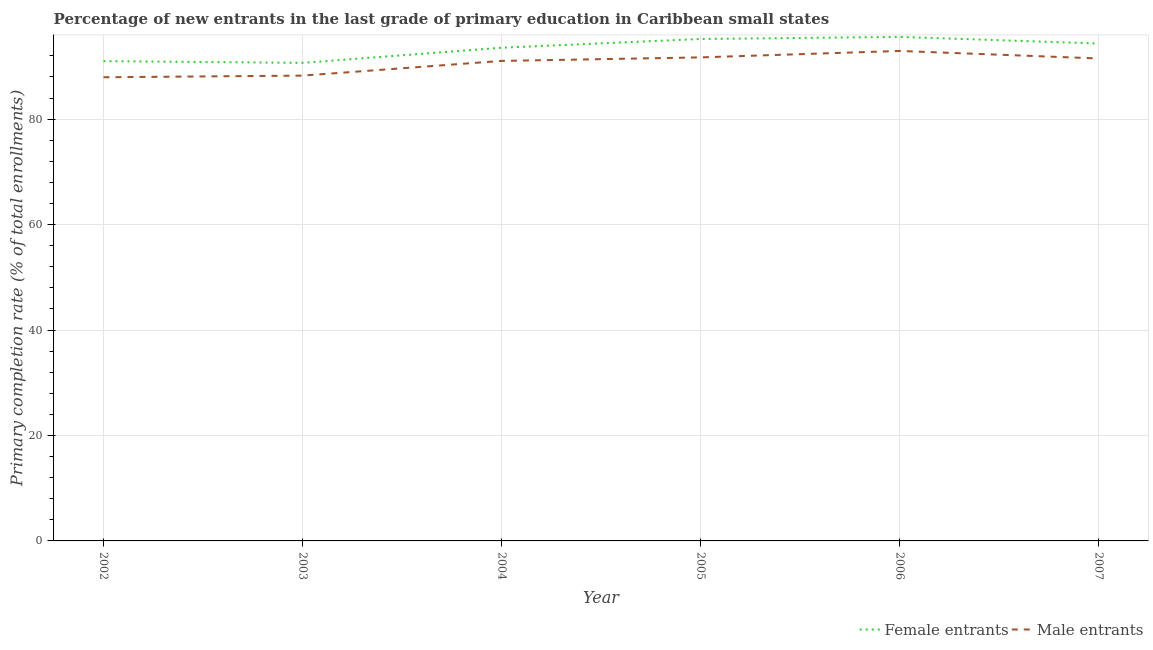How many different coloured lines are there?
Ensure brevity in your answer.  2. Does the line corresponding to primary completion rate of female entrants intersect with the line corresponding to primary completion rate of male entrants?
Keep it short and to the point. No. What is the primary completion rate of female entrants in 2006?
Make the answer very short. 95.59. Across all years, what is the maximum primary completion rate of female entrants?
Provide a succinct answer. 95.59. Across all years, what is the minimum primary completion rate of female entrants?
Give a very brief answer. 90.66. In which year was the primary completion rate of male entrants minimum?
Ensure brevity in your answer.  2002. What is the total primary completion rate of female entrants in the graph?
Your answer should be compact. 560.32. What is the difference between the primary completion rate of male entrants in 2002 and that in 2005?
Provide a short and direct response. -3.77. What is the difference between the primary completion rate of female entrants in 2007 and the primary completion rate of male entrants in 2002?
Your response must be concise. 6.4. What is the average primary completion rate of male entrants per year?
Your response must be concise. 90.56. In the year 2006, what is the difference between the primary completion rate of male entrants and primary completion rate of female entrants?
Provide a short and direct response. -2.66. In how many years, is the primary completion rate of female entrants greater than 76 %?
Make the answer very short. 6. What is the ratio of the primary completion rate of male entrants in 2002 to that in 2004?
Provide a succinct answer. 0.97. What is the difference between the highest and the second highest primary completion rate of male entrants?
Provide a short and direct response. 1.22. What is the difference between the highest and the lowest primary completion rate of male entrants?
Ensure brevity in your answer.  4.99. In how many years, is the primary completion rate of female entrants greater than the average primary completion rate of female entrants taken over all years?
Your answer should be compact. 4. Is the sum of the primary completion rate of male entrants in 2003 and 2004 greater than the maximum primary completion rate of female entrants across all years?
Provide a short and direct response. Yes. Does the primary completion rate of male entrants monotonically increase over the years?
Your response must be concise. No. How many years are there in the graph?
Ensure brevity in your answer.  6. What is the difference between two consecutive major ticks on the Y-axis?
Your answer should be compact. 20. Does the graph contain grids?
Make the answer very short. Yes. How are the legend labels stacked?
Your answer should be compact. Horizontal. What is the title of the graph?
Provide a succinct answer. Percentage of new entrants in the last grade of primary education in Caribbean small states. Does "International Visitors" appear as one of the legend labels in the graph?
Keep it short and to the point. No. What is the label or title of the Y-axis?
Your answer should be compact. Primary completion rate (% of total enrollments). What is the Primary completion rate (% of total enrollments) in Female entrants in 2002?
Keep it short and to the point. 90.99. What is the Primary completion rate (% of total enrollments) in Male entrants in 2002?
Ensure brevity in your answer.  87.94. What is the Primary completion rate (% of total enrollments) in Female entrants in 2003?
Make the answer very short. 90.66. What is the Primary completion rate (% of total enrollments) of Male entrants in 2003?
Make the answer very short. 88.25. What is the Primary completion rate (% of total enrollments) of Female entrants in 2004?
Make the answer very short. 93.54. What is the Primary completion rate (% of total enrollments) in Male entrants in 2004?
Give a very brief answer. 91.04. What is the Primary completion rate (% of total enrollments) in Female entrants in 2005?
Give a very brief answer. 95.19. What is the Primary completion rate (% of total enrollments) of Male entrants in 2005?
Your response must be concise. 91.71. What is the Primary completion rate (% of total enrollments) in Female entrants in 2006?
Give a very brief answer. 95.59. What is the Primary completion rate (% of total enrollments) of Male entrants in 2006?
Provide a succinct answer. 92.93. What is the Primary completion rate (% of total enrollments) of Female entrants in 2007?
Keep it short and to the point. 94.34. What is the Primary completion rate (% of total enrollments) in Male entrants in 2007?
Your answer should be compact. 91.5. Across all years, what is the maximum Primary completion rate (% of total enrollments) in Female entrants?
Offer a terse response. 95.59. Across all years, what is the maximum Primary completion rate (% of total enrollments) of Male entrants?
Provide a short and direct response. 92.93. Across all years, what is the minimum Primary completion rate (% of total enrollments) in Female entrants?
Offer a terse response. 90.66. Across all years, what is the minimum Primary completion rate (% of total enrollments) of Male entrants?
Ensure brevity in your answer.  87.94. What is the total Primary completion rate (% of total enrollments) in Female entrants in the graph?
Offer a very short reply. 560.32. What is the total Primary completion rate (% of total enrollments) of Male entrants in the graph?
Your response must be concise. 543.35. What is the difference between the Primary completion rate (% of total enrollments) in Female entrants in 2002 and that in 2003?
Make the answer very short. 0.33. What is the difference between the Primary completion rate (% of total enrollments) in Male entrants in 2002 and that in 2003?
Provide a short and direct response. -0.31. What is the difference between the Primary completion rate (% of total enrollments) in Female entrants in 2002 and that in 2004?
Give a very brief answer. -2.54. What is the difference between the Primary completion rate (% of total enrollments) of Male entrants in 2002 and that in 2004?
Make the answer very short. -3.1. What is the difference between the Primary completion rate (% of total enrollments) of Female entrants in 2002 and that in 2005?
Offer a terse response. -4.2. What is the difference between the Primary completion rate (% of total enrollments) in Male entrants in 2002 and that in 2005?
Make the answer very short. -3.77. What is the difference between the Primary completion rate (% of total enrollments) of Female entrants in 2002 and that in 2006?
Offer a very short reply. -4.6. What is the difference between the Primary completion rate (% of total enrollments) in Male entrants in 2002 and that in 2006?
Ensure brevity in your answer.  -4.99. What is the difference between the Primary completion rate (% of total enrollments) in Female entrants in 2002 and that in 2007?
Make the answer very short. -3.34. What is the difference between the Primary completion rate (% of total enrollments) of Male entrants in 2002 and that in 2007?
Ensure brevity in your answer.  -3.56. What is the difference between the Primary completion rate (% of total enrollments) in Female entrants in 2003 and that in 2004?
Provide a short and direct response. -2.87. What is the difference between the Primary completion rate (% of total enrollments) in Male entrants in 2003 and that in 2004?
Offer a very short reply. -2.79. What is the difference between the Primary completion rate (% of total enrollments) of Female entrants in 2003 and that in 2005?
Your answer should be compact. -4.53. What is the difference between the Primary completion rate (% of total enrollments) of Male entrants in 2003 and that in 2005?
Keep it short and to the point. -3.46. What is the difference between the Primary completion rate (% of total enrollments) of Female entrants in 2003 and that in 2006?
Offer a terse response. -4.93. What is the difference between the Primary completion rate (% of total enrollments) of Male entrants in 2003 and that in 2006?
Keep it short and to the point. -4.68. What is the difference between the Primary completion rate (% of total enrollments) in Female entrants in 2003 and that in 2007?
Provide a succinct answer. -3.67. What is the difference between the Primary completion rate (% of total enrollments) of Male entrants in 2003 and that in 2007?
Your answer should be very brief. -3.25. What is the difference between the Primary completion rate (% of total enrollments) of Female entrants in 2004 and that in 2005?
Your answer should be very brief. -1.66. What is the difference between the Primary completion rate (% of total enrollments) of Male entrants in 2004 and that in 2005?
Give a very brief answer. -0.67. What is the difference between the Primary completion rate (% of total enrollments) of Female entrants in 2004 and that in 2006?
Provide a short and direct response. -2.05. What is the difference between the Primary completion rate (% of total enrollments) in Male entrants in 2004 and that in 2006?
Keep it short and to the point. -1.89. What is the difference between the Primary completion rate (% of total enrollments) of Female entrants in 2004 and that in 2007?
Provide a succinct answer. -0.8. What is the difference between the Primary completion rate (% of total enrollments) of Male entrants in 2004 and that in 2007?
Ensure brevity in your answer.  -0.46. What is the difference between the Primary completion rate (% of total enrollments) of Female entrants in 2005 and that in 2006?
Your answer should be compact. -0.4. What is the difference between the Primary completion rate (% of total enrollments) of Male entrants in 2005 and that in 2006?
Make the answer very short. -1.22. What is the difference between the Primary completion rate (% of total enrollments) of Female entrants in 2005 and that in 2007?
Give a very brief answer. 0.86. What is the difference between the Primary completion rate (% of total enrollments) of Male entrants in 2005 and that in 2007?
Provide a short and direct response. 0.21. What is the difference between the Primary completion rate (% of total enrollments) in Female entrants in 2006 and that in 2007?
Keep it short and to the point. 1.25. What is the difference between the Primary completion rate (% of total enrollments) in Male entrants in 2006 and that in 2007?
Provide a short and direct response. 1.43. What is the difference between the Primary completion rate (% of total enrollments) of Female entrants in 2002 and the Primary completion rate (% of total enrollments) of Male entrants in 2003?
Ensure brevity in your answer.  2.75. What is the difference between the Primary completion rate (% of total enrollments) of Female entrants in 2002 and the Primary completion rate (% of total enrollments) of Male entrants in 2004?
Ensure brevity in your answer.  -0.04. What is the difference between the Primary completion rate (% of total enrollments) of Female entrants in 2002 and the Primary completion rate (% of total enrollments) of Male entrants in 2005?
Ensure brevity in your answer.  -0.71. What is the difference between the Primary completion rate (% of total enrollments) of Female entrants in 2002 and the Primary completion rate (% of total enrollments) of Male entrants in 2006?
Make the answer very short. -1.93. What is the difference between the Primary completion rate (% of total enrollments) of Female entrants in 2002 and the Primary completion rate (% of total enrollments) of Male entrants in 2007?
Offer a terse response. -0.5. What is the difference between the Primary completion rate (% of total enrollments) of Female entrants in 2003 and the Primary completion rate (% of total enrollments) of Male entrants in 2004?
Offer a terse response. -0.37. What is the difference between the Primary completion rate (% of total enrollments) of Female entrants in 2003 and the Primary completion rate (% of total enrollments) of Male entrants in 2005?
Your response must be concise. -1.04. What is the difference between the Primary completion rate (% of total enrollments) of Female entrants in 2003 and the Primary completion rate (% of total enrollments) of Male entrants in 2006?
Provide a succinct answer. -2.26. What is the difference between the Primary completion rate (% of total enrollments) in Female entrants in 2003 and the Primary completion rate (% of total enrollments) in Male entrants in 2007?
Ensure brevity in your answer.  -0.83. What is the difference between the Primary completion rate (% of total enrollments) in Female entrants in 2004 and the Primary completion rate (% of total enrollments) in Male entrants in 2005?
Provide a short and direct response. 1.83. What is the difference between the Primary completion rate (% of total enrollments) of Female entrants in 2004 and the Primary completion rate (% of total enrollments) of Male entrants in 2006?
Give a very brief answer. 0.61. What is the difference between the Primary completion rate (% of total enrollments) in Female entrants in 2004 and the Primary completion rate (% of total enrollments) in Male entrants in 2007?
Give a very brief answer. 2.04. What is the difference between the Primary completion rate (% of total enrollments) of Female entrants in 2005 and the Primary completion rate (% of total enrollments) of Male entrants in 2006?
Keep it short and to the point. 2.27. What is the difference between the Primary completion rate (% of total enrollments) of Female entrants in 2005 and the Primary completion rate (% of total enrollments) of Male entrants in 2007?
Your answer should be compact. 3.7. What is the difference between the Primary completion rate (% of total enrollments) of Female entrants in 2006 and the Primary completion rate (% of total enrollments) of Male entrants in 2007?
Give a very brief answer. 4.09. What is the average Primary completion rate (% of total enrollments) of Female entrants per year?
Provide a succinct answer. 93.39. What is the average Primary completion rate (% of total enrollments) of Male entrants per year?
Offer a terse response. 90.56. In the year 2002, what is the difference between the Primary completion rate (% of total enrollments) of Female entrants and Primary completion rate (% of total enrollments) of Male entrants?
Offer a very short reply. 3.06. In the year 2003, what is the difference between the Primary completion rate (% of total enrollments) in Female entrants and Primary completion rate (% of total enrollments) in Male entrants?
Your answer should be compact. 2.42. In the year 2004, what is the difference between the Primary completion rate (% of total enrollments) in Female entrants and Primary completion rate (% of total enrollments) in Male entrants?
Ensure brevity in your answer.  2.5. In the year 2005, what is the difference between the Primary completion rate (% of total enrollments) in Female entrants and Primary completion rate (% of total enrollments) in Male entrants?
Your answer should be compact. 3.49. In the year 2006, what is the difference between the Primary completion rate (% of total enrollments) in Female entrants and Primary completion rate (% of total enrollments) in Male entrants?
Your answer should be compact. 2.66. In the year 2007, what is the difference between the Primary completion rate (% of total enrollments) in Female entrants and Primary completion rate (% of total enrollments) in Male entrants?
Keep it short and to the point. 2.84. What is the ratio of the Primary completion rate (% of total enrollments) in Female entrants in 2002 to that in 2003?
Keep it short and to the point. 1. What is the ratio of the Primary completion rate (% of total enrollments) of Male entrants in 2002 to that in 2003?
Ensure brevity in your answer.  1. What is the ratio of the Primary completion rate (% of total enrollments) in Female entrants in 2002 to that in 2004?
Provide a short and direct response. 0.97. What is the ratio of the Primary completion rate (% of total enrollments) in Female entrants in 2002 to that in 2005?
Offer a terse response. 0.96. What is the ratio of the Primary completion rate (% of total enrollments) of Male entrants in 2002 to that in 2005?
Your response must be concise. 0.96. What is the ratio of the Primary completion rate (% of total enrollments) of Female entrants in 2002 to that in 2006?
Your answer should be compact. 0.95. What is the ratio of the Primary completion rate (% of total enrollments) of Male entrants in 2002 to that in 2006?
Keep it short and to the point. 0.95. What is the ratio of the Primary completion rate (% of total enrollments) of Female entrants in 2002 to that in 2007?
Offer a terse response. 0.96. What is the ratio of the Primary completion rate (% of total enrollments) of Male entrants in 2002 to that in 2007?
Offer a terse response. 0.96. What is the ratio of the Primary completion rate (% of total enrollments) in Female entrants in 2003 to that in 2004?
Provide a short and direct response. 0.97. What is the ratio of the Primary completion rate (% of total enrollments) of Male entrants in 2003 to that in 2004?
Give a very brief answer. 0.97. What is the ratio of the Primary completion rate (% of total enrollments) in Female entrants in 2003 to that in 2005?
Keep it short and to the point. 0.95. What is the ratio of the Primary completion rate (% of total enrollments) of Male entrants in 2003 to that in 2005?
Offer a terse response. 0.96. What is the ratio of the Primary completion rate (% of total enrollments) of Female entrants in 2003 to that in 2006?
Give a very brief answer. 0.95. What is the ratio of the Primary completion rate (% of total enrollments) of Male entrants in 2003 to that in 2006?
Your answer should be very brief. 0.95. What is the ratio of the Primary completion rate (% of total enrollments) in Male entrants in 2003 to that in 2007?
Offer a terse response. 0.96. What is the ratio of the Primary completion rate (% of total enrollments) in Female entrants in 2004 to that in 2005?
Provide a succinct answer. 0.98. What is the ratio of the Primary completion rate (% of total enrollments) in Male entrants in 2004 to that in 2005?
Your answer should be compact. 0.99. What is the ratio of the Primary completion rate (% of total enrollments) of Female entrants in 2004 to that in 2006?
Offer a very short reply. 0.98. What is the ratio of the Primary completion rate (% of total enrollments) in Male entrants in 2004 to that in 2006?
Your answer should be compact. 0.98. What is the ratio of the Primary completion rate (% of total enrollments) of Female entrants in 2004 to that in 2007?
Your response must be concise. 0.99. What is the ratio of the Primary completion rate (% of total enrollments) in Male entrants in 2005 to that in 2006?
Your answer should be very brief. 0.99. What is the ratio of the Primary completion rate (% of total enrollments) in Female entrants in 2005 to that in 2007?
Provide a short and direct response. 1.01. What is the ratio of the Primary completion rate (% of total enrollments) in Female entrants in 2006 to that in 2007?
Offer a very short reply. 1.01. What is the ratio of the Primary completion rate (% of total enrollments) of Male entrants in 2006 to that in 2007?
Give a very brief answer. 1.02. What is the difference between the highest and the second highest Primary completion rate (% of total enrollments) of Female entrants?
Your answer should be very brief. 0.4. What is the difference between the highest and the second highest Primary completion rate (% of total enrollments) of Male entrants?
Offer a terse response. 1.22. What is the difference between the highest and the lowest Primary completion rate (% of total enrollments) in Female entrants?
Give a very brief answer. 4.93. What is the difference between the highest and the lowest Primary completion rate (% of total enrollments) in Male entrants?
Provide a short and direct response. 4.99. 